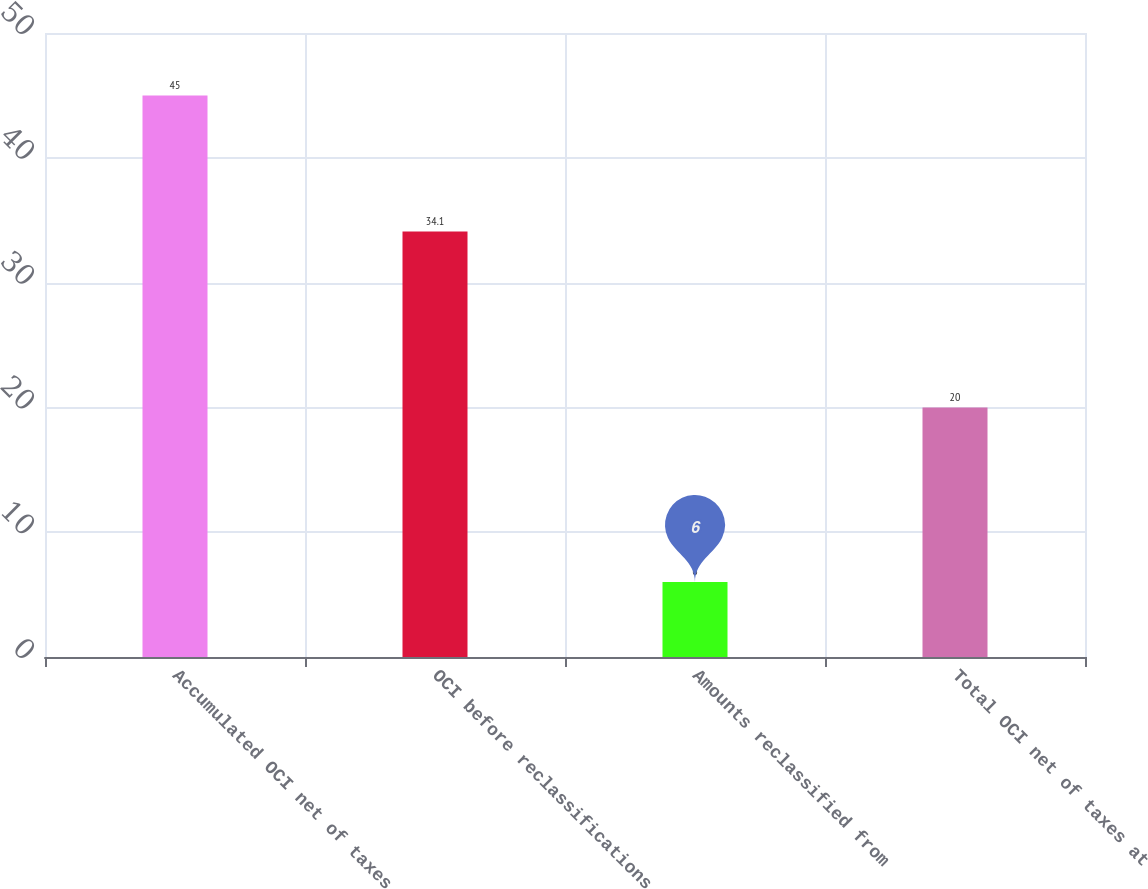Convert chart to OTSL. <chart><loc_0><loc_0><loc_500><loc_500><bar_chart><fcel>Accumulated OCI net of taxes<fcel>OCI before reclassifications<fcel>Amounts reclassified from<fcel>Total OCI net of taxes at<nl><fcel>45<fcel>34.1<fcel>6<fcel>20<nl></chart> 